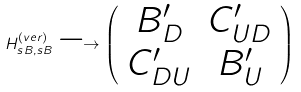<formula> <loc_0><loc_0><loc_500><loc_500>H ^ { ( v e r ) } _ { s B , s B } \longrightarrow \left ( \begin{array} { c c } B ^ { \prime } _ { D } & C ^ { \prime } _ { U D } \\ C ^ { \prime } _ { D U } & B ^ { \prime } _ { U } \end{array} \right )</formula> 